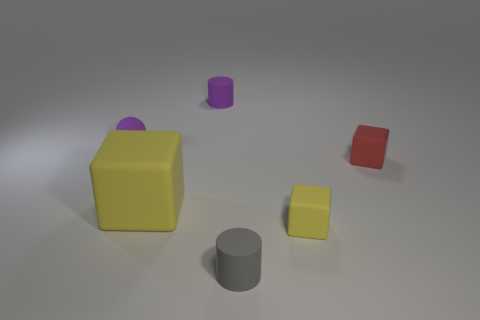What size is the matte cylinder behind the red rubber object?
Provide a short and direct response. Small. There is a yellow block that is on the left side of the small rubber cylinder that is left of the small cylinder that is in front of the red matte object; what is its size?
Provide a short and direct response. Large. What color is the matte cylinder to the right of the thing behind the matte sphere?
Your response must be concise. Gray. There is a big yellow object that is the same shape as the red matte object; what material is it?
Offer a very short reply. Rubber. Are there any tiny red rubber cubes to the right of the tiny gray matte cylinder?
Your answer should be very brief. Yes. What number of big green cubes are there?
Offer a very short reply. 0. What number of yellow matte objects are behind the tiny matte cube in front of the red rubber cube?
Your response must be concise. 1. There is a big matte block; is it the same color as the small block that is in front of the red rubber cube?
Give a very brief answer. Yes. What number of large yellow things have the same shape as the red rubber object?
Make the answer very short. 1. There is a large thing left of the tiny red rubber thing; is its shape the same as the small red object?
Give a very brief answer. Yes. 